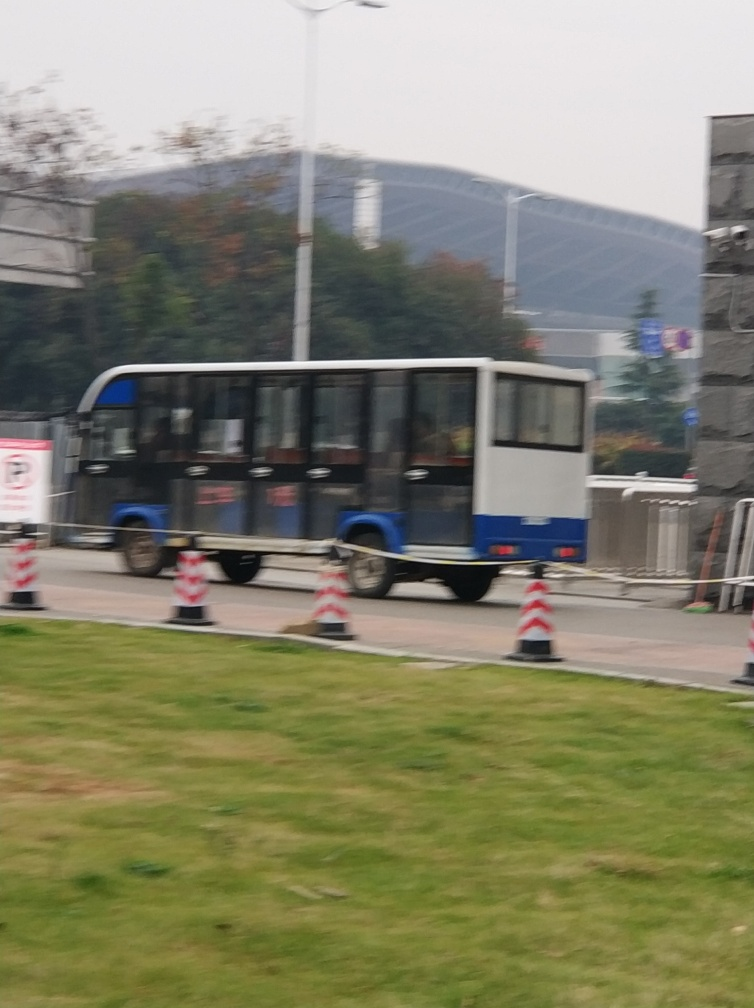How busy does the street seem at the moment? The street doesn't appear to be very busy. There is a single bus in view and a few traffic cones indicating potential road work or lane closures. Overall, traffic seems light. 